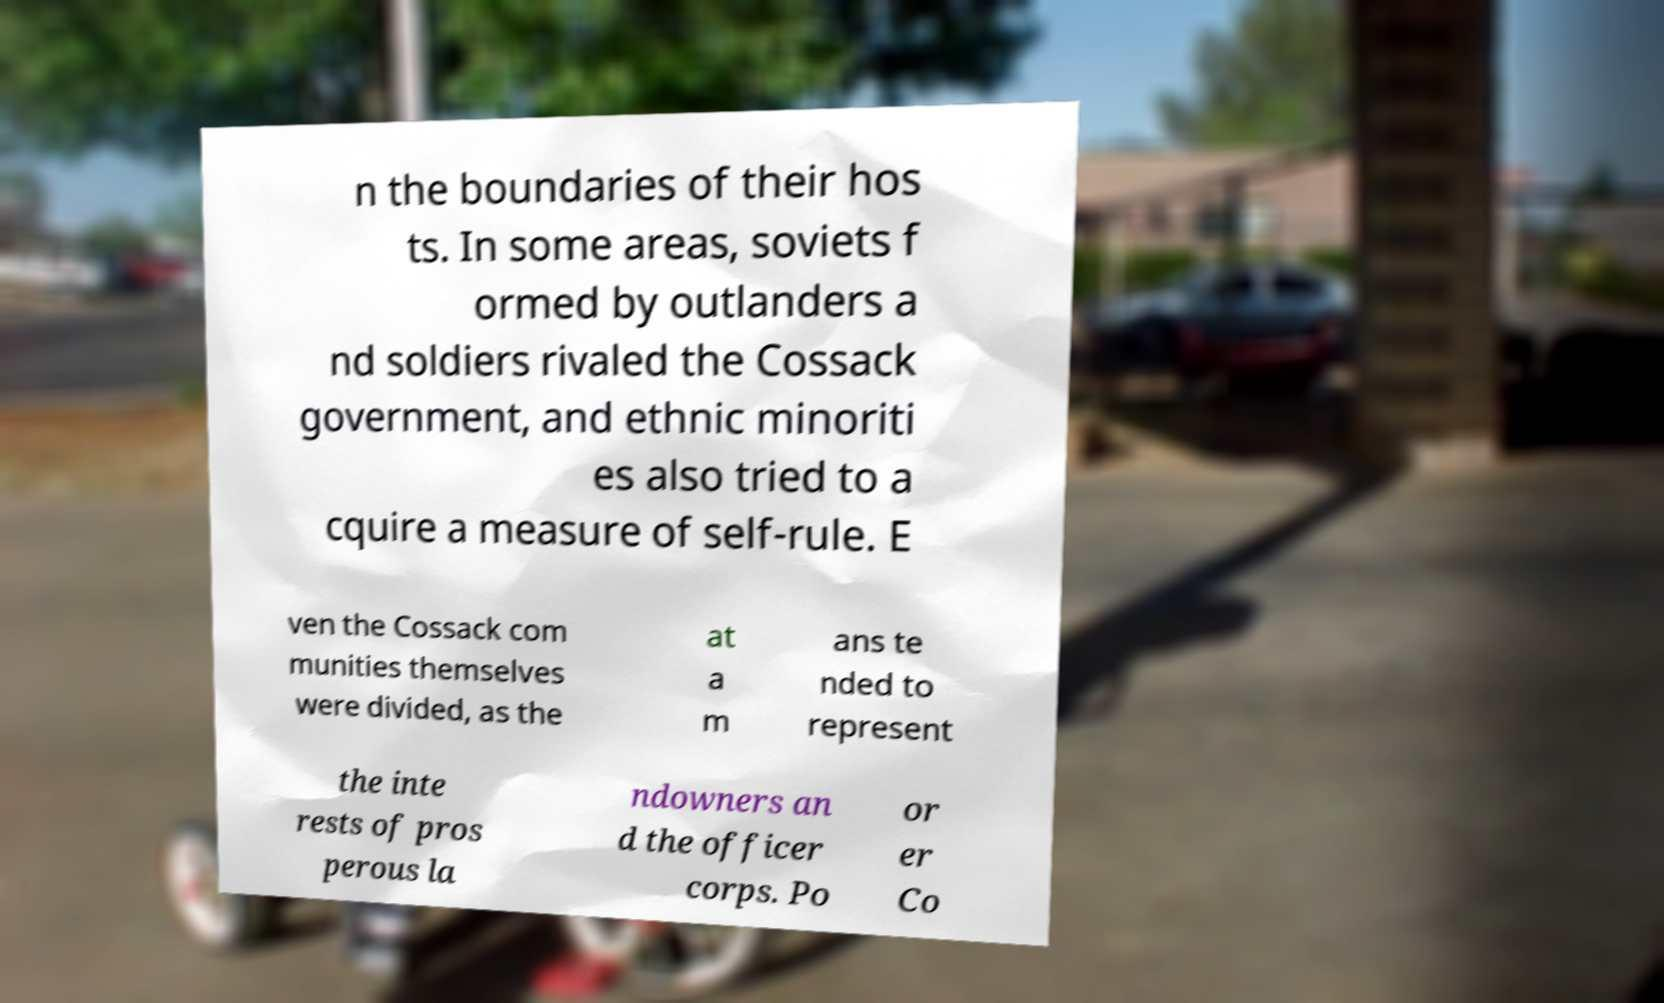Can you read and provide the text displayed in the image?This photo seems to have some interesting text. Can you extract and type it out for me? n the boundaries of their hos ts. In some areas, soviets f ormed by outlanders a nd soldiers rivaled the Cossack government, and ethnic minoriti es also tried to a cquire a measure of self-rule. E ven the Cossack com munities themselves were divided, as the at a m ans te nded to represent the inte rests of pros perous la ndowners an d the officer corps. Po or er Co 